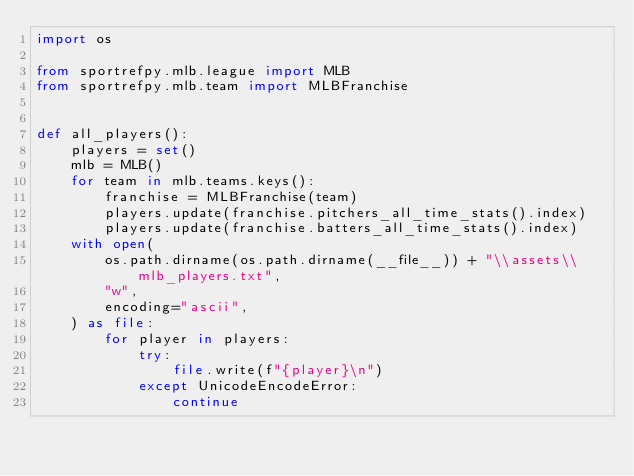<code> <loc_0><loc_0><loc_500><loc_500><_Python_>import os

from sportrefpy.mlb.league import MLB
from sportrefpy.mlb.team import MLBFranchise


def all_players():
    players = set()
    mlb = MLB()
    for team in mlb.teams.keys():
        franchise = MLBFranchise(team)
        players.update(franchise.pitchers_all_time_stats().index)
        players.update(franchise.batters_all_time_stats().index)
    with open(
        os.path.dirname(os.path.dirname(__file__)) + "\\assets\\mlb_players.txt",
        "w",
        encoding="ascii",
    ) as file:
        for player in players:
            try:
                file.write(f"{player}\n")
            except UnicodeEncodeError:
                continue
</code> 